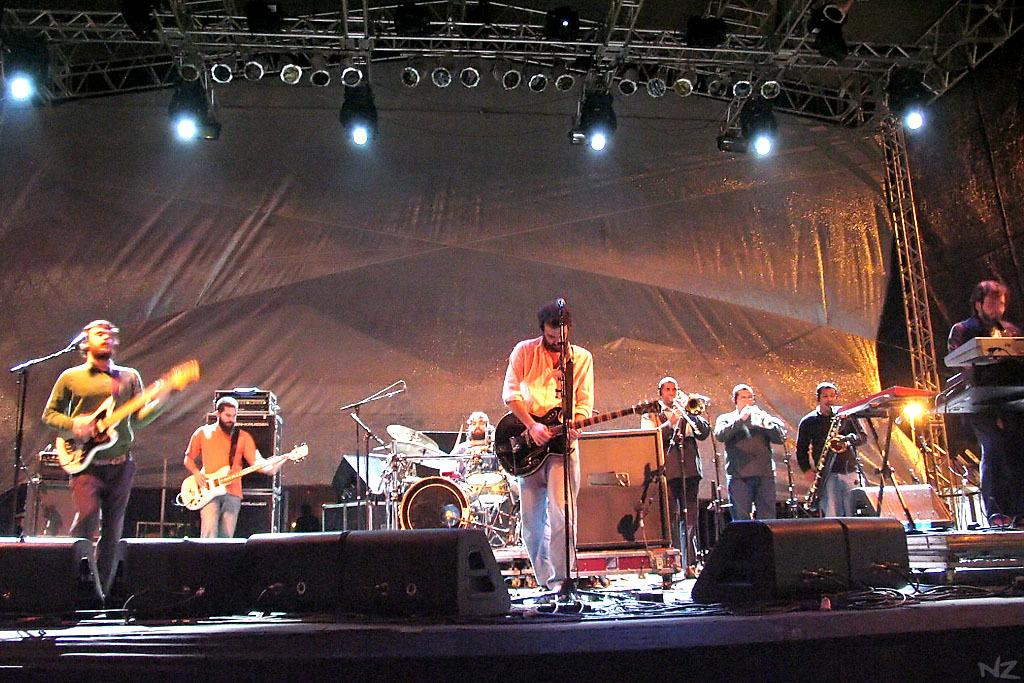What is the person in the image holding? The person is holding a cup of coffee. What activity is the person in the image engaged in? The person is reading a newspaper. Can you describe the setting of the image? The person is sitting around a table. What might be the purpose of the newspaper in the image? The person might be reading the news or catching up on current events. What type of substance is the cow cooking in the image? There is no cow or cooking activity present in the image. 